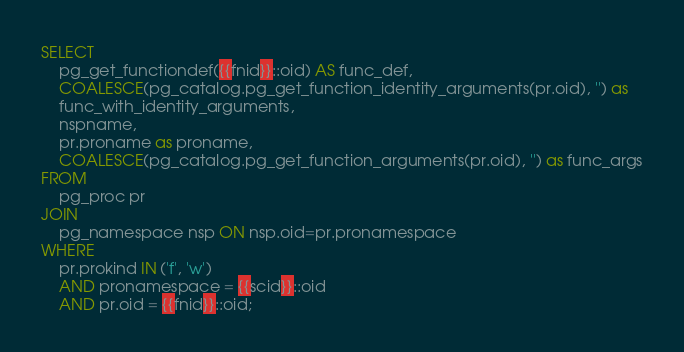Convert code to text. <code><loc_0><loc_0><loc_500><loc_500><_SQL_>SELECT
    pg_get_functiondef({{fnid}}::oid) AS func_def,
    COALESCE(pg_catalog.pg_get_function_identity_arguments(pr.oid), '') as
    func_with_identity_arguments,
    nspname,
    pr.proname as proname,
    COALESCE(pg_catalog.pg_get_function_arguments(pr.oid), '') as func_args
FROM
    pg_proc pr
JOIN
    pg_namespace nsp ON nsp.oid=pr.pronamespace
WHERE
    pr.prokind IN ('f', 'w')
    AND pronamespace = {{scid}}::oid
    AND pr.oid = {{fnid}}::oid;
</code> 